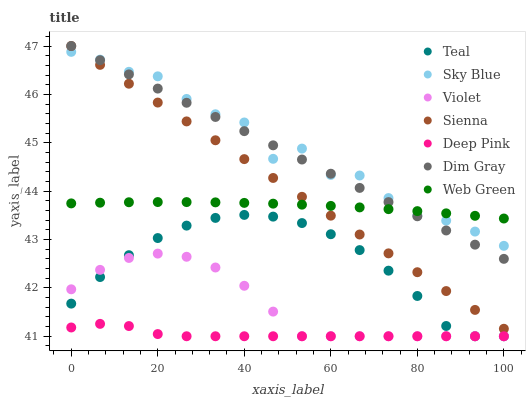Does Deep Pink have the minimum area under the curve?
Answer yes or no. Yes. Does Sky Blue have the maximum area under the curve?
Answer yes or no. Yes. Does Web Green have the minimum area under the curve?
Answer yes or no. No. Does Web Green have the maximum area under the curve?
Answer yes or no. No. Is Sienna the smoothest?
Answer yes or no. Yes. Is Sky Blue the roughest?
Answer yes or no. Yes. Is Web Green the smoothest?
Answer yes or no. No. Is Web Green the roughest?
Answer yes or no. No. Does Deep Pink have the lowest value?
Answer yes or no. Yes. Does Sienna have the lowest value?
Answer yes or no. No. Does Sienna have the highest value?
Answer yes or no. Yes. Does Web Green have the highest value?
Answer yes or no. No. Is Deep Pink less than Dim Gray?
Answer yes or no. Yes. Is Sienna greater than Teal?
Answer yes or no. Yes. Does Web Green intersect Dim Gray?
Answer yes or no. Yes. Is Web Green less than Dim Gray?
Answer yes or no. No. Is Web Green greater than Dim Gray?
Answer yes or no. No. Does Deep Pink intersect Dim Gray?
Answer yes or no. No. 